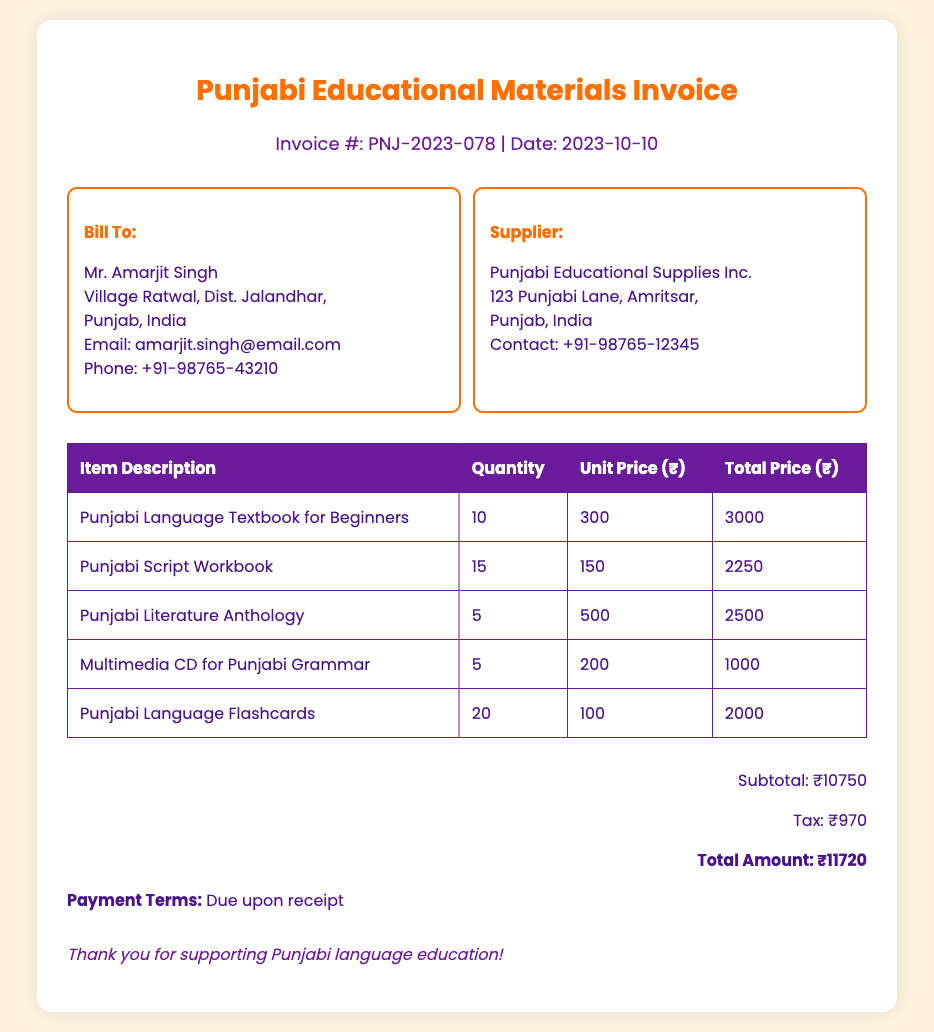What is the invoice number? The invoice number can be found in the header of the document.
Answer: PNJ-2023-078 What is the date of the invoice? The date of the invoice is specified in the header section.
Answer: 2023-10-10 Who is the billed recipient? The billed recipient's name is stated in the "Bill To" section.
Answer: Mr. Amarjit Singh How many Punjabi Language Textbooks were purchased? The quantity purchased for the Punjabi Language Textbooks is listed in the items table.
Answer: 10 What is the total amount after tax? The total amount can be calculated by adding the subtotal and tax amounts listed in the document.
Answer: ₹11720 What is the subtotal of the invoice? The subtotal amount before tax is mentioned in the total section of the invoice.
Answer: ₹10750 Which item has the highest unit price? The unit prices for each item are compared in the table to identify the item with the highest price.
Answer: Punjabi Literature Anthology What type of materials were purchased? The nature of the materials can be determined by reading the item descriptions in the table.
Answer: Educational Materials What are the payment terms? The payment terms are explicitly stated at the bottom of the invoice document.
Answer: Due upon receipt 